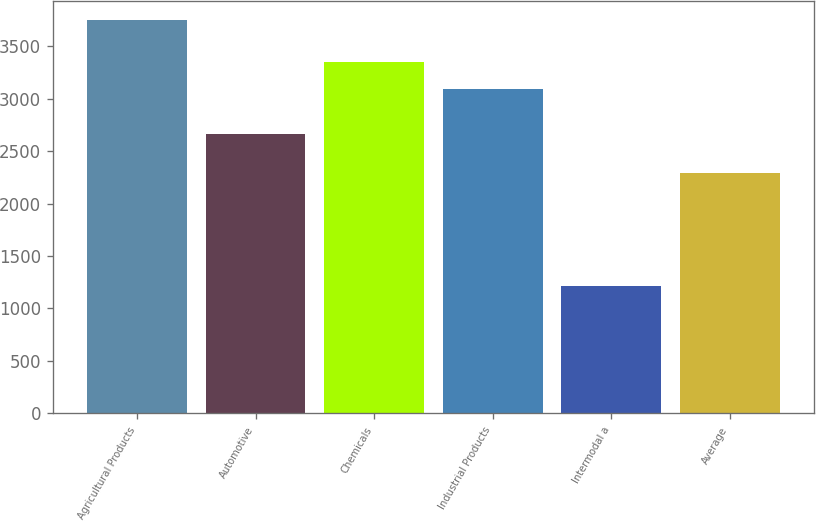<chart> <loc_0><loc_0><loc_500><loc_500><bar_chart><fcel>Agricultural Products<fcel>Automotive<fcel>Chemicals<fcel>Industrial Products<fcel>Intermodal a<fcel>Average<nl><fcel>3746<fcel>2659<fcel>3346.4<fcel>3093<fcel>1212<fcel>2293<nl></chart> 